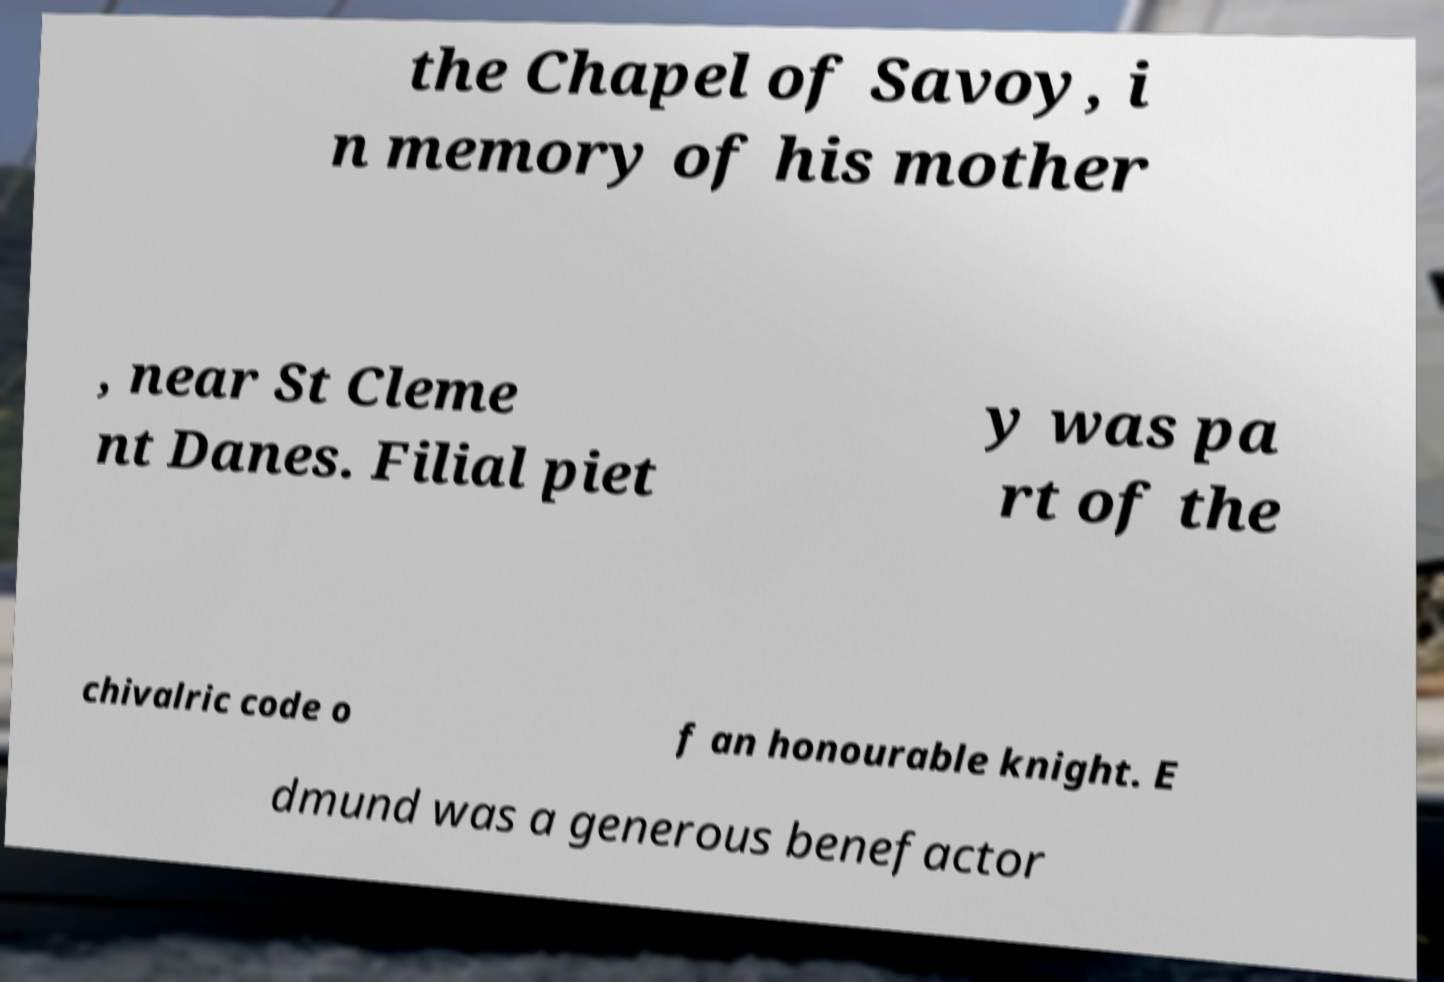Please identify and transcribe the text found in this image. the Chapel of Savoy, i n memory of his mother , near St Cleme nt Danes. Filial piet y was pa rt of the chivalric code o f an honourable knight. E dmund was a generous benefactor 